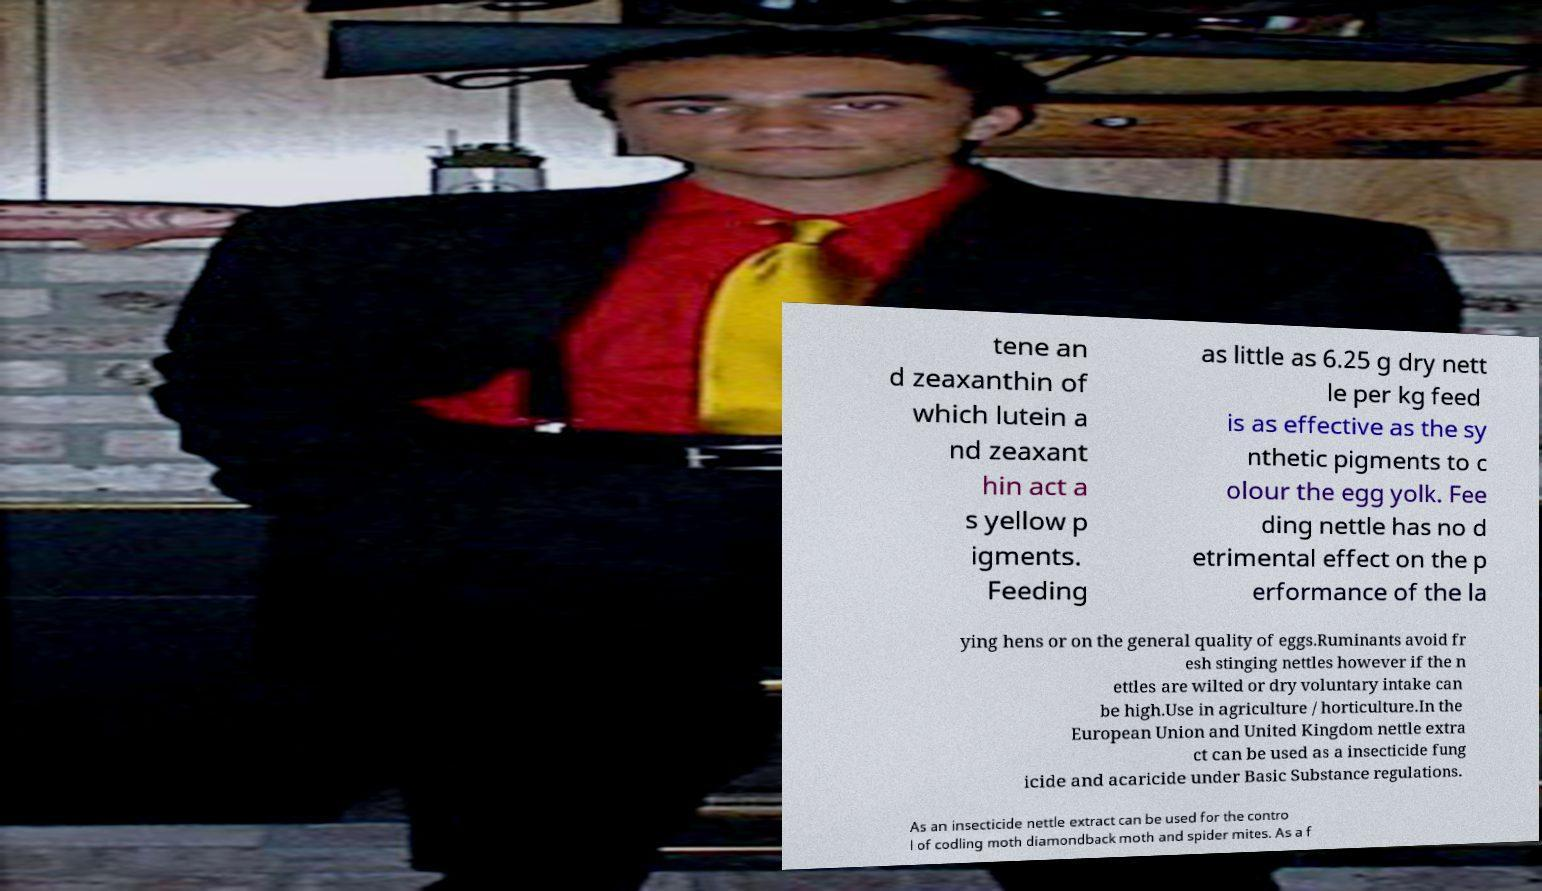What messages or text are displayed in this image? I need them in a readable, typed format. tene an d zeaxanthin of which lutein a nd zeaxant hin act a s yellow p igments. Feeding as little as 6.25 g dry nett le per kg feed is as effective as the sy nthetic pigments to c olour the egg yolk. Fee ding nettle has no d etrimental effect on the p erformance of the la ying hens or on the general quality of eggs.Ruminants avoid fr esh stinging nettles however if the n ettles are wilted or dry voluntary intake can be high.Use in agriculture / horticulture.In the European Union and United Kingdom nettle extra ct can be used as a insecticide fung icide and acaricide under Basic Substance regulations. As an insecticide nettle extract can be used for the contro l of codling moth diamondback moth and spider mites. As a f 